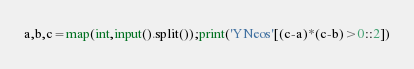<code> <loc_0><loc_0><loc_500><loc_500><_Python_>a,b,c=map(int,input().split());print('YNeos'[(c-a)*(c-b)>0::2])</code> 